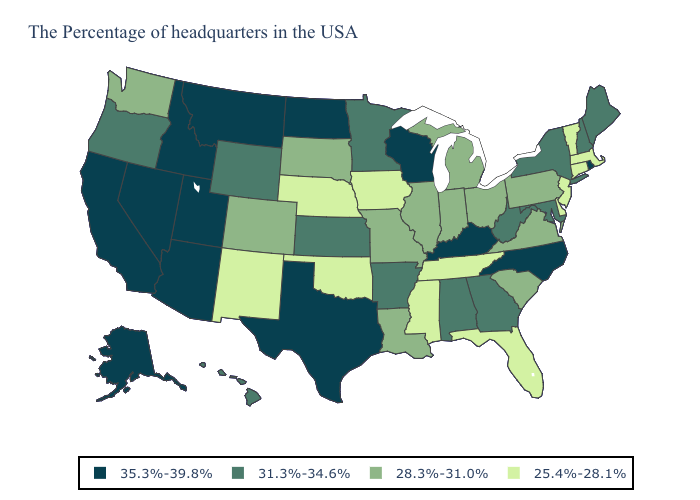Name the states that have a value in the range 28.3%-31.0%?
Short answer required. Pennsylvania, Virginia, South Carolina, Ohio, Michigan, Indiana, Illinois, Louisiana, Missouri, South Dakota, Colorado, Washington. What is the value of Oklahoma?
Be succinct. 25.4%-28.1%. Among the states that border North Dakota , which have the lowest value?
Concise answer only. South Dakota. Does California have the lowest value in the West?
Be succinct. No. Which states hav the highest value in the MidWest?
Keep it brief. Wisconsin, North Dakota. What is the highest value in the USA?
Be succinct. 35.3%-39.8%. Which states have the lowest value in the MidWest?
Short answer required. Iowa, Nebraska. Name the states that have a value in the range 28.3%-31.0%?
Short answer required. Pennsylvania, Virginia, South Carolina, Ohio, Michigan, Indiana, Illinois, Louisiana, Missouri, South Dakota, Colorado, Washington. Name the states that have a value in the range 35.3%-39.8%?
Write a very short answer. Rhode Island, North Carolina, Kentucky, Wisconsin, Texas, North Dakota, Utah, Montana, Arizona, Idaho, Nevada, California, Alaska. What is the value of New Jersey?
Answer briefly. 25.4%-28.1%. Name the states that have a value in the range 35.3%-39.8%?
Be succinct. Rhode Island, North Carolina, Kentucky, Wisconsin, Texas, North Dakota, Utah, Montana, Arizona, Idaho, Nevada, California, Alaska. What is the highest value in the West ?
Be succinct. 35.3%-39.8%. Does Oklahoma have the lowest value in the USA?
Keep it brief. Yes. Name the states that have a value in the range 35.3%-39.8%?
Quick response, please. Rhode Island, North Carolina, Kentucky, Wisconsin, Texas, North Dakota, Utah, Montana, Arizona, Idaho, Nevada, California, Alaska. What is the value of New Hampshire?
Write a very short answer. 31.3%-34.6%. 